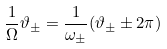<formula> <loc_0><loc_0><loc_500><loc_500>\frac { 1 } { \Omega } \vartheta _ { \pm } = \frac { 1 } { \omega _ { \pm } } ( \vartheta _ { \pm } \pm 2 \pi )</formula> 